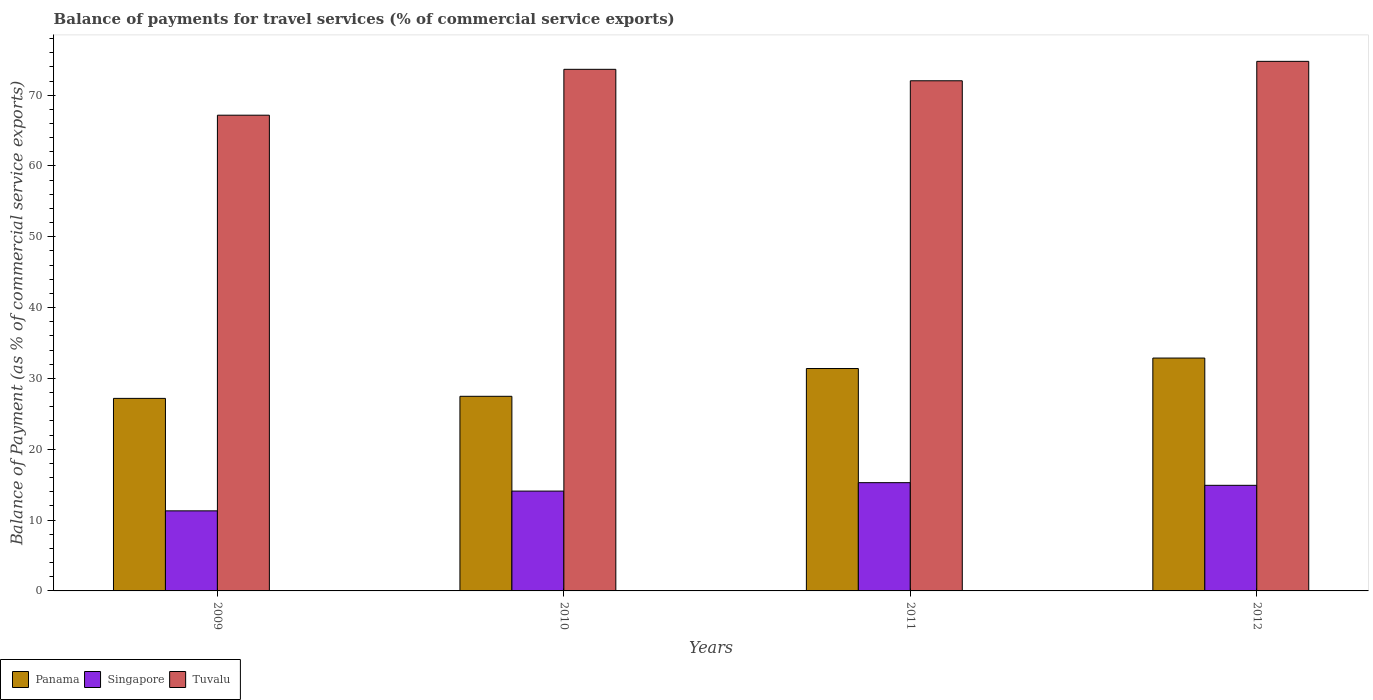How many different coloured bars are there?
Ensure brevity in your answer.  3. Are the number of bars on each tick of the X-axis equal?
Keep it short and to the point. Yes. How many bars are there on the 4th tick from the left?
Make the answer very short. 3. How many bars are there on the 2nd tick from the right?
Offer a terse response. 3. In how many cases, is the number of bars for a given year not equal to the number of legend labels?
Offer a very short reply. 0. What is the balance of payments for travel services in Tuvalu in 2010?
Your answer should be very brief. 73.65. Across all years, what is the maximum balance of payments for travel services in Singapore?
Your answer should be very brief. 15.29. Across all years, what is the minimum balance of payments for travel services in Panama?
Your answer should be compact. 27.19. What is the total balance of payments for travel services in Tuvalu in the graph?
Keep it short and to the point. 287.63. What is the difference between the balance of payments for travel services in Singapore in 2009 and that in 2010?
Provide a succinct answer. -2.79. What is the difference between the balance of payments for travel services in Singapore in 2009 and the balance of payments for travel services in Panama in 2012?
Your answer should be compact. -21.57. What is the average balance of payments for travel services in Singapore per year?
Provide a short and direct response. 13.9. In the year 2009, what is the difference between the balance of payments for travel services in Panama and balance of payments for travel services in Singapore?
Offer a very short reply. 15.88. What is the ratio of the balance of payments for travel services in Tuvalu in 2009 to that in 2010?
Offer a terse response. 0.91. Is the balance of payments for travel services in Panama in 2010 less than that in 2012?
Ensure brevity in your answer.  Yes. Is the difference between the balance of payments for travel services in Panama in 2009 and 2011 greater than the difference between the balance of payments for travel services in Singapore in 2009 and 2011?
Ensure brevity in your answer.  No. What is the difference between the highest and the second highest balance of payments for travel services in Panama?
Give a very brief answer. 1.48. What is the difference between the highest and the lowest balance of payments for travel services in Panama?
Give a very brief answer. 5.69. In how many years, is the balance of payments for travel services in Panama greater than the average balance of payments for travel services in Panama taken over all years?
Ensure brevity in your answer.  2. What does the 2nd bar from the left in 2010 represents?
Give a very brief answer. Singapore. What does the 3rd bar from the right in 2012 represents?
Your response must be concise. Panama. Are all the bars in the graph horizontal?
Give a very brief answer. No. How many years are there in the graph?
Give a very brief answer. 4. Does the graph contain grids?
Provide a succinct answer. No. How are the legend labels stacked?
Offer a terse response. Horizontal. What is the title of the graph?
Keep it short and to the point. Balance of payments for travel services (% of commercial service exports). Does "Marshall Islands" appear as one of the legend labels in the graph?
Provide a succinct answer. No. What is the label or title of the X-axis?
Make the answer very short. Years. What is the label or title of the Y-axis?
Provide a short and direct response. Balance of Payment (as % of commercial service exports). What is the Balance of Payment (as % of commercial service exports) of Panama in 2009?
Ensure brevity in your answer.  27.19. What is the Balance of Payment (as % of commercial service exports) of Singapore in 2009?
Give a very brief answer. 11.31. What is the Balance of Payment (as % of commercial service exports) in Tuvalu in 2009?
Offer a terse response. 67.17. What is the Balance of Payment (as % of commercial service exports) of Panama in 2010?
Keep it short and to the point. 27.48. What is the Balance of Payment (as % of commercial service exports) of Singapore in 2010?
Ensure brevity in your answer.  14.1. What is the Balance of Payment (as % of commercial service exports) in Tuvalu in 2010?
Ensure brevity in your answer.  73.65. What is the Balance of Payment (as % of commercial service exports) of Panama in 2011?
Offer a terse response. 31.4. What is the Balance of Payment (as % of commercial service exports) in Singapore in 2011?
Ensure brevity in your answer.  15.29. What is the Balance of Payment (as % of commercial service exports) of Tuvalu in 2011?
Your response must be concise. 72.03. What is the Balance of Payment (as % of commercial service exports) in Panama in 2012?
Provide a succinct answer. 32.88. What is the Balance of Payment (as % of commercial service exports) of Singapore in 2012?
Offer a very short reply. 14.91. What is the Balance of Payment (as % of commercial service exports) of Tuvalu in 2012?
Offer a terse response. 74.77. Across all years, what is the maximum Balance of Payment (as % of commercial service exports) of Panama?
Your response must be concise. 32.88. Across all years, what is the maximum Balance of Payment (as % of commercial service exports) of Singapore?
Your response must be concise. 15.29. Across all years, what is the maximum Balance of Payment (as % of commercial service exports) of Tuvalu?
Ensure brevity in your answer.  74.77. Across all years, what is the minimum Balance of Payment (as % of commercial service exports) in Panama?
Offer a terse response. 27.19. Across all years, what is the minimum Balance of Payment (as % of commercial service exports) of Singapore?
Give a very brief answer. 11.31. Across all years, what is the minimum Balance of Payment (as % of commercial service exports) in Tuvalu?
Provide a succinct answer. 67.17. What is the total Balance of Payment (as % of commercial service exports) of Panama in the graph?
Ensure brevity in your answer.  118.95. What is the total Balance of Payment (as % of commercial service exports) of Singapore in the graph?
Offer a very short reply. 55.6. What is the total Balance of Payment (as % of commercial service exports) of Tuvalu in the graph?
Keep it short and to the point. 287.63. What is the difference between the Balance of Payment (as % of commercial service exports) of Panama in 2009 and that in 2010?
Ensure brevity in your answer.  -0.29. What is the difference between the Balance of Payment (as % of commercial service exports) in Singapore in 2009 and that in 2010?
Provide a succinct answer. -2.79. What is the difference between the Balance of Payment (as % of commercial service exports) in Tuvalu in 2009 and that in 2010?
Provide a short and direct response. -6.48. What is the difference between the Balance of Payment (as % of commercial service exports) of Panama in 2009 and that in 2011?
Make the answer very short. -4.22. What is the difference between the Balance of Payment (as % of commercial service exports) of Singapore in 2009 and that in 2011?
Give a very brief answer. -3.98. What is the difference between the Balance of Payment (as % of commercial service exports) of Tuvalu in 2009 and that in 2011?
Provide a short and direct response. -4.86. What is the difference between the Balance of Payment (as % of commercial service exports) in Panama in 2009 and that in 2012?
Offer a terse response. -5.69. What is the difference between the Balance of Payment (as % of commercial service exports) of Singapore in 2009 and that in 2012?
Provide a short and direct response. -3.6. What is the difference between the Balance of Payment (as % of commercial service exports) of Tuvalu in 2009 and that in 2012?
Provide a succinct answer. -7.6. What is the difference between the Balance of Payment (as % of commercial service exports) in Panama in 2010 and that in 2011?
Offer a very short reply. -3.92. What is the difference between the Balance of Payment (as % of commercial service exports) in Singapore in 2010 and that in 2011?
Provide a succinct answer. -1.19. What is the difference between the Balance of Payment (as % of commercial service exports) in Tuvalu in 2010 and that in 2011?
Keep it short and to the point. 1.62. What is the difference between the Balance of Payment (as % of commercial service exports) in Panama in 2010 and that in 2012?
Offer a very short reply. -5.4. What is the difference between the Balance of Payment (as % of commercial service exports) in Singapore in 2010 and that in 2012?
Provide a short and direct response. -0.81. What is the difference between the Balance of Payment (as % of commercial service exports) of Tuvalu in 2010 and that in 2012?
Offer a terse response. -1.12. What is the difference between the Balance of Payment (as % of commercial service exports) in Panama in 2011 and that in 2012?
Your response must be concise. -1.48. What is the difference between the Balance of Payment (as % of commercial service exports) in Singapore in 2011 and that in 2012?
Provide a succinct answer. 0.38. What is the difference between the Balance of Payment (as % of commercial service exports) of Tuvalu in 2011 and that in 2012?
Ensure brevity in your answer.  -2.74. What is the difference between the Balance of Payment (as % of commercial service exports) of Panama in 2009 and the Balance of Payment (as % of commercial service exports) of Singapore in 2010?
Keep it short and to the point. 13.09. What is the difference between the Balance of Payment (as % of commercial service exports) in Panama in 2009 and the Balance of Payment (as % of commercial service exports) in Tuvalu in 2010?
Ensure brevity in your answer.  -46.46. What is the difference between the Balance of Payment (as % of commercial service exports) in Singapore in 2009 and the Balance of Payment (as % of commercial service exports) in Tuvalu in 2010?
Offer a terse response. -62.34. What is the difference between the Balance of Payment (as % of commercial service exports) of Panama in 2009 and the Balance of Payment (as % of commercial service exports) of Singapore in 2011?
Ensure brevity in your answer.  11.9. What is the difference between the Balance of Payment (as % of commercial service exports) in Panama in 2009 and the Balance of Payment (as % of commercial service exports) in Tuvalu in 2011?
Provide a succinct answer. -44.85. What is the difference between the Balance of Payment (as % of commercial service exports) in Singapore in 2009 and the Balance of Payment (as % of commercial service exports) in Tuvalu in 2011?
Provide a short and direct response. -60.73. What is the difference between the Balance of Payment (as % of commercial service exports) of Panama in 2009 and the Balance of Payment (as % of commercial service exports) of Singapore in 2012?
Provide a short and direct response. 12.28. What is the difference between the Balance of Payment (as % of commercial service exports) in Panama in 2009 and the Balance of Payment (as % of commercial service exports) in Tuvalu in 2012?
Your answer should be very brief. -47.59. What is the difference between the Balance of Payment (as % of commercial service exports) of Singapore in 2009 and the Balance of Payment (as % of commercial service exports) of Tuvalu in 2012?
Offer a terse response. -63.47. What is the difference between the Balance of Payment (as % of commercial service exports) of Panama in 2010 and the Balance of Payment (as % of commercial service exports) of Singapore in 2011?
Keep it short and to the point. 12.19. What is the difference between the Balance of Payment (as % of commercial service exports) of Panama in 2010 and the Balance of Payment (as % of commercial service exports) of Tuvalu in 2011?
Offer a very short reply. -44.55. What is the difference between the Balance of Payment (as % of commercial service exports) of Singapore in 2010 and the Balance of Payment (as % of commercial service exports) of Tuvalu in 2011?
Your response must be concise. -57.94. What is the difference between the Balance of Payment (as % of commercial service exports) in Panama in 2010 and the Balance of Payment (as % of commercial service exports) in Singapore in 2012?
Keep it short and to the point. 12.57. What is the difference between the Balance of Payment (as % of commercial service exports) of Panama in 2010 and the Balance of Payment (as % of commercial service exports) of Tuvalu in 2012?
Ensure brevity in your answer.  -47.3. What is the difference between the Balance of Payment (as % of commercial service exports) of Singapore in 2010 and the Balance of Payment (as % of commercial service exports) of Tuvalu in 2012?
Your answer should be compact. -60.68. What is the difference between the Balance of Payment (as % of commercial service exports) in Panama in 2011 and the Balance of Payment (as % of commercial service exports) in Singapore in 2012?
Your response must be concise. 16.49. What is the difference between the Balance of Payment (as % of commercial service exports) of Panama in 2011 and the Balance of Payment (as % of commercial service exports) of Tuvalu in 2012?
Make the answer very short. -43.37. What is the difference between the Balance of Payment (as % of commercial service exports) of Singapore in 2011 and the Balance of Payment (as % of commercial service exports) of Tuvalu in 2012?
Ensure brevity in your answer.  -59.49. What is the average Balance of Payment (as % of commercial service exports) of Panama per year?
Ensure brevity in your answer.  29.74. What is the average Balance of Payment (as % of commercial service exports) of Singapore per year?
Your answer should be compact. 13.9. What is the average Balance of Payment (as % of commercial service exports) in Tuvalu per year?
Give a very brief answer. 71.91. In the year 2009, what is the difference between the Balance of Payment (as % of commercial service exports) of Panama and Balance of Payment (as % of commercial service exports) of Singapore?
Offer a very short reply. 15.88. In the year 2009, what is the difference between the Balance of Payment (as % of commercial service exports) of Panama and Balance of Payment (as % of commercial service exports) of Tuvalu?
Keep it short and to the point. -39.99. In the year 2009, what is the difference between the Balance of Payment (as % of commercial service exports) of Singapore and Balance of Payment (as % of commercial service exports) of Tuvalu?
Ensure brevity in your answer.  -55.87. In the year 2010, what is the difference between the Balance of Payment (as % of commercial service exports) in Panama and Balance of Payment (as % of commercial service exports) in Singapore?
Keep it short and to the point. 13.38. In the year 2010, what is the difference between the Balance of Payment (as % of commercial service exports) in Panama and Balance of Payment (as % of commercial service exports) in Tuvalu?
Give a very brief answer. -46.17. In the year 2010, what is the difference between the Balance of Payment (as % of commercial service exports) in Singapore and Balance of Payment (as % of commercial service exports) in Tuvalu?
Make the answer very short. -59.55. In the year 2011, what is the difference between the Balance of Payment (as % of commercial service exports) of Panama and Balance of Payment (as % of commercial service exports) of Singapore?
Your response must be concise. 16.12. In the year 2011, what is the difference between the Balance of Payment (as % of commercial service exports) of Panama and Balance of Payment (as % of commercial service exports) of Tuvalu?
Keep it short and to the point. -40.63. In the year 2011, what is the difference between the Balance of Payment (as % of commercial service exports) of Singapore and Balance of Payment (as % of commercial service exports) of Tuvalu?
Make the answer very short. -56.75. In the year 2012, what is the difference between the Balance of Payment (as % of commercial service exports) of Panama and Balance of Payment (as % of commercial service exports) of Singapore?
Offer a very short reply. 17.97. In the year 2012, what is the difference between the Balance of Payment (as % of commercial service exports) of Panama and Balance of Payment (as % of commercial service exports) of Tuvalu?
Keep it short and to the point. -41.89. In the year 2012, what is the difference between the Balance of Payment (as % of commercial service exports) of Singapore and Balance of Payment (as % of commercial service exports) of Tuvalu?
Offer a terse response. -59.86. What is the ratio of the Balance of Payment (as % of commercial service exports) of Panama in 2009 to that in 2010?
Provide a short and direct response. 0.99. What is the ratio of the Balance of Payment (as % of commercial service exports) in Singapore in 2009 to that in 2010?
Give a very brief answer. 0.8. What is the ratio of the Balance of Payment (as % of commercial service exports) of Tuvalu in 2009 to that in 2010?
Give a very brief answer. 0.91. What is the ratio of the Balance of Payment (as % of commercial service exports) of Panama in 2009 to that in 2011?
Your answer should be compact. 0.87. What is the ratio of the Balance of Payment (as % of commercial service exports) of Singapore in 2009 to that in 2011?
Ensure brevity in your answer.  0.74. What is the ratio of the Balance of Payment (as % of commercial service exports) in Tuvalu in 2009 to that in 2011?
Keep it short and to the point. 0.93. What is the ratio of the Balance of Payment (as % of commercial service exports) of Panama in 2009 to that in 2012?
Provide a succinct answer. 0.83. What is the ratio of the Balance of Payment (as % of commercial service exports) in Singapore in 2009 to that in 2012?
Give a very brief answer. 0.76. What is the ratio of the Balance of Payment (as % of commercial service exports) in Tuvalu in 2009 to that in 2012?
Your answer should be compact. 0.9. What is the ratio of the Balance of Payment (as % of commercial service exports) in Singapore in 2010 to that in 2011?
Offer a terse response. 0.92. What is the ratio of the Balance of Payment (as % of commercial service exports) of Tuvalu in 2010 to that in 2011?
Your response must be concise. 1.02. What is the ratio of the Balance of Payment (as % of commercial service exports) of Panama in 2010 to that in 2012?
Keep it short and to the point. 0.84. What is the ratio of the Balance of Payment (as % of commercial service exports) of Singapore in 2010 to that in 2012?
Give a very brief answer. 0.95. What is the ratio of the Balance of Payment (as % of commercial service exports) of Panama in 2011 to that in 2012?
Make the answer very short. 0.96. What is the ratio of the Balance of Payment (as % of commercial service exports) of Singapore in 2011 to that in 2012?
Offer a very short reply. 1.03. What is the ratio of the Balance of Payment (as % of commercial service exports) of Tuvalu in 2011 to that in 2012?
Your answer should be compact. 0.96. What is the difference between the highest and the second highest Balance of Payment (as % of commercial service exports) in Panama?
Offer a terse response. 1.48. What is the difference between the highest and the second highest Balance of Payment (as % of commercial service exports) of Singapore?
Offer a terse response. 0.38. What is the difference between the highest and the second highest Balance of Payment (as % of commercial service exports) of Tuvalu?
Give a very brief answer. 1.12. What is the difference between the highest and the lowest Balance of Payment (as % of commercial service exports) in Panama?
Your response must be concise. 5.69. What is the difference between the highest and the lowest Balance of Payment (as % of commercial service exports) of Singapore?
Your answer should be compact. 3.98. What is the difference between the highest and the lowest Balance of Payment (as % of commercial service exports) of Tuvalu?
Make the answer very short. 7.6. 